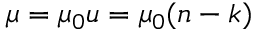Convert formula to latex. <formula><loc_0><loc_0><loc_500><loc_500>\mu = \mu _ { 0 } u = \mu _ { 0 } ( n - k )</formula> 